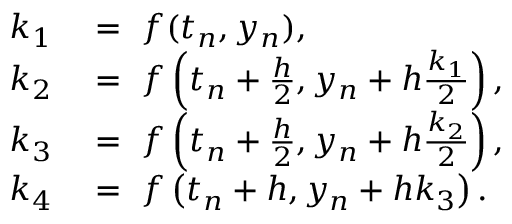<formula> <loc_0><loc_0><loc_500><loc_500>\begin{array} { r l } { k _ { 1 } } & = \ f ( t _ { n } , y _ { n } ) , } \\ { k _ { 2 } } & = \ f \left ( t _ { n } + { \frac { h } { 2 } } , y _ { n } + h { \frac { k _ { 1 } } { 2 } } \right ) , } \\ { k _ { 3 } } & = \ f \left ( t _ { n } + { \frac { h } { 2 } } , y _ { n } + h { \frac { k _ { 2 } } { 2 } } \right ) , } \\ { k _ { 4 } } & = \ f \left ( t _ { n } + h , y _ { n } + h k _ { 3 } \right ) . } \end{array}</formula> 